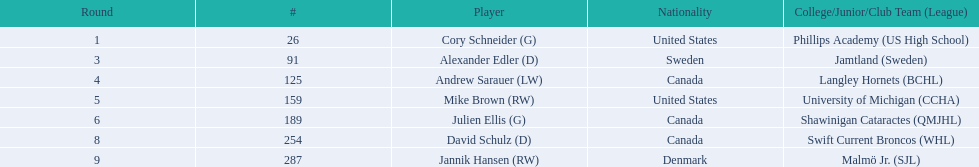Could you help me parse every detail presented in this table? {'header': ['Round', '#', 'Player', 'Nationality', 'College/Junior/Club Team (League)'], 'rows': [['1', '26', 'Cory Schneider (G)', 'United States', 'Phillips Academy (US High School)'], ['3', '91', 'Alexander Edler (D)', 'Sweden', 'Jamtland (Sweden)'], ['4', '125', 'Andrew Sarauer (LW)', 'Canada', 'Langley Hornets (BCHL)'], ['5', '159', 'Mike Brown (RW)', 'United States', 'University of Michigan (CCHA)'], ['6', '189', 'Julien Ellis (G)', 'Canada', 'Shawinigan Cataractes (QMJHL)'], ['8', '254', 'David Schulz (D)', 'Canada', 'Swift Current Broncos (WHL)'], ['9', '287', 'Jannik Hansen (RW)', 'Denmark', 'Malmö Jr. (SJL)']]} What are the players' nationalities? United States, Sweden, Canada, United States, Canada, Canada, Denmark. Who among them has denmark as their nationality? Jannik Hansen (RW). 